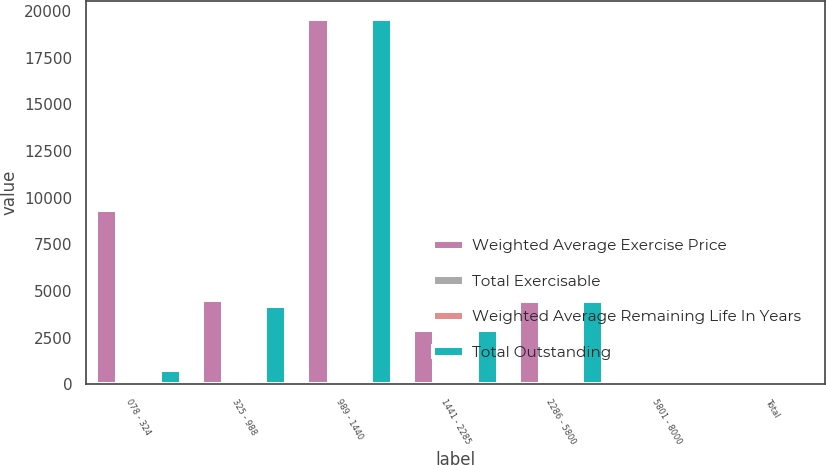Convert chart to OTSL. <chart><loc_0><loc_0><loc_500><loc_500><stacked_bar_chart><ecel><fcel>078 - 324<fcel>325 - 988<fcel>989 - 1440<fcel>1441 - 2285<fcel>2286 - 5800<fcel>5801 - 8000<fcel>Total<nl><fcel>Weighted Average Exercise Price<fcel>9359<fcel>4519<fcel>19580<fcel>2887<fcel>4462<fcel>9<fcel>15.72<nl><fcel>Total Exercisable<fcel>9<fcel>2.2<fcel>7.4<fcel>4.7<fcel>6.5<fcel>6.7<fcel>6.9<nl><fcel>Weighted Average Remaining Life In Years<fcel>2.75<fcel>5.51<fcel>13.03<fcel>17.85<fcel>44.11<fcel>61.42<fcel>13.59<nl><fcel>Total Outstanding<fcel>761<fcel>4211<fcel>19580<fcel>2886<fcel>4456<fcel>9<fcel>15.72<nl></chart> 